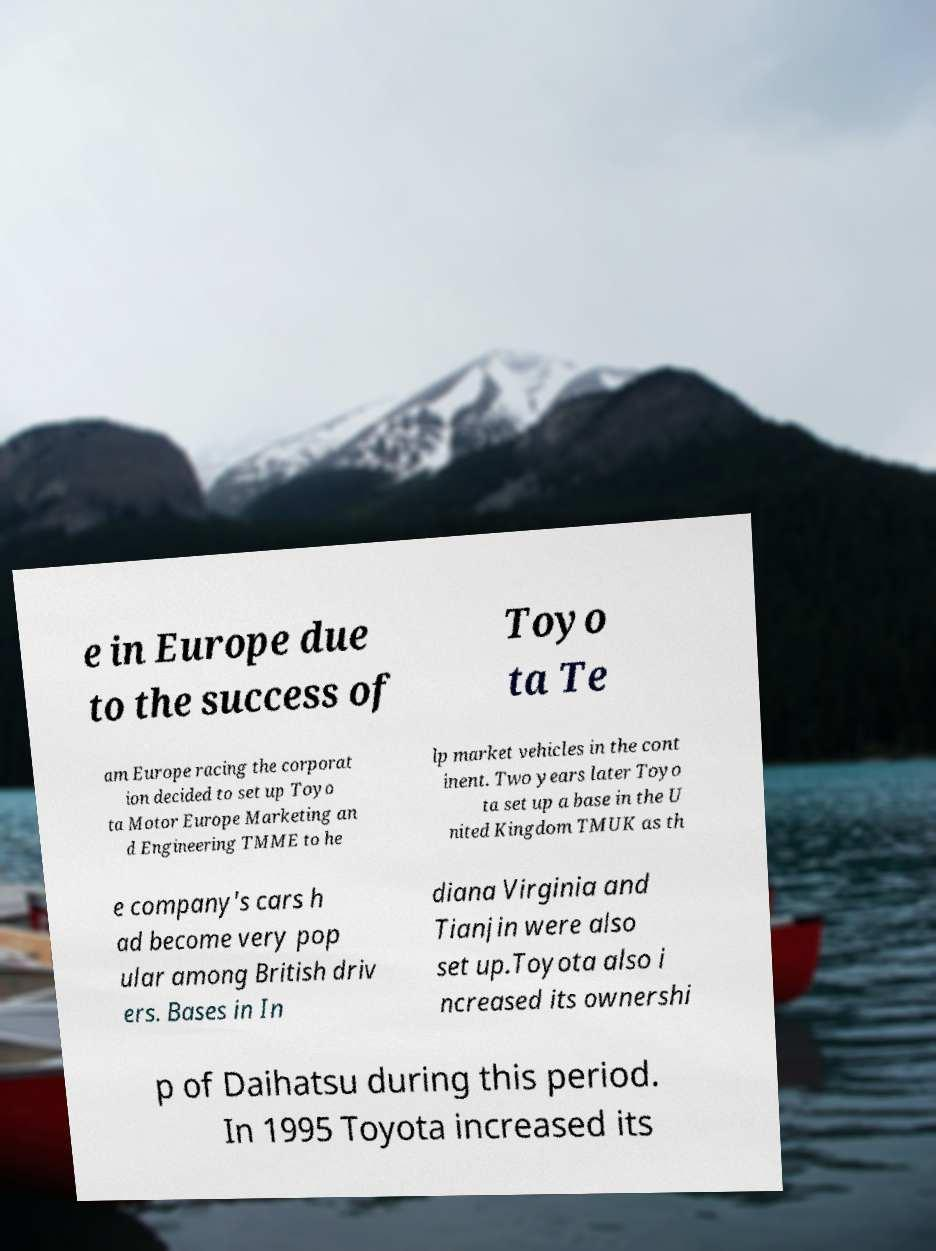Can you read and provide the text displayed in the image?This photo seems to have some interesting text. Can you extract and type it out for me? e in Europe due to the success of Toyo ta Te am Europe racing the corporat ion decided to set up Toyo ta Motor Europe Marketing an d Engineering TMME to he lp market vehicles in the cont inent. Two years later Toyo ta set up a base in the U nited Kingdom TMUK as th e company's cars h ad become very pop ular among British driv ers. Bases in In diana Virginia and Tianjin were also set up.Toyota also i ncreased its ownershi p of Daihatsu during this period. In 1995 Toyota increased its 